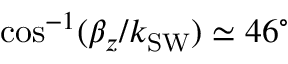<formula> <loc_0><loc_0><loc_500><loc_500>\cos ^ { - 1 } ( \beta _ { z } / k _ { S W } ) \simeq 4 6 ^ { \circ }</formula> 